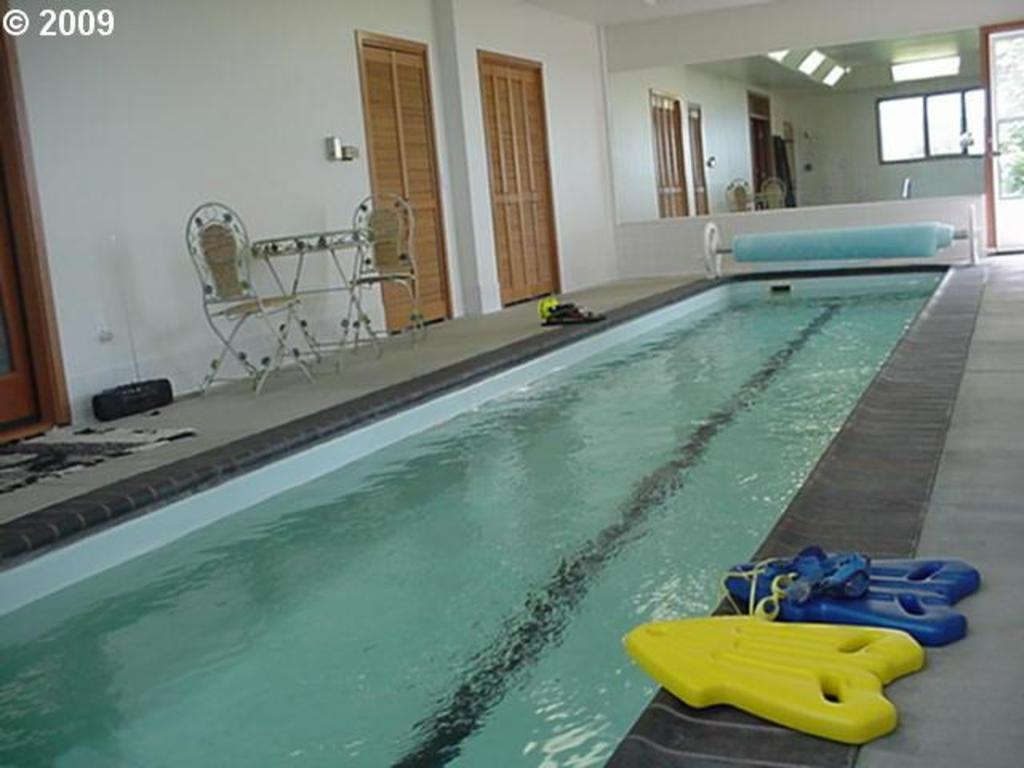What is the main feature of the image? There is a swimming pool in the image. What safety equipment is present in the image? Safety jackets are present in the image. What furniture is visible in the image? Side tables and chairs are present in the image. What items are used for cleaning or decoration in the image? Doormats are in the image. What architectural features can be seen in the image? Doors and windows are visible in the image. What part of the setting is visible in the image? The floor is visible in the image. What type of jelly is being cooked on the stove in the image? There is no stove or jelly present in the image; it features a swimming pool and related items. 